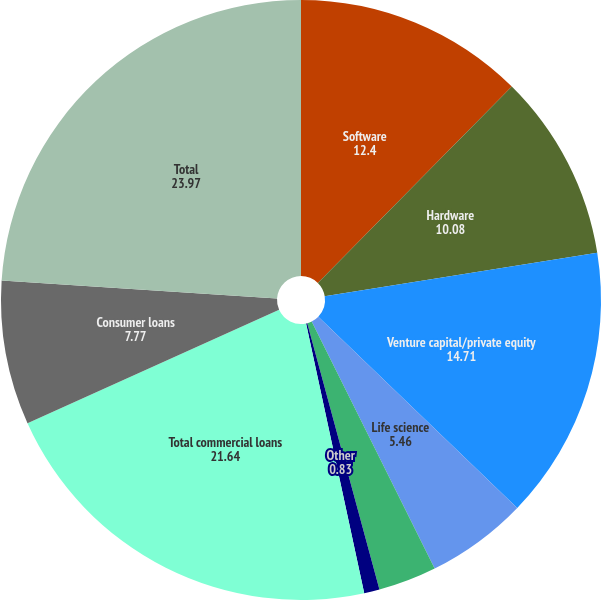<chart> <loc_0><loc_0><loc_500><loc_500><pie_chart><fcel>Software<fcel>Hardware<fcel>Venture capital/private equity<fcel>Life science<fcel>Premium wine<fcel>Other<fcel>Total commercial loans<fcel>Consumer loans<fcel>Total<nl><fcel>12.4%<fcel>10.08%<fcel>14.71%<fcel>5.46%<fcel>3.14%<fcel>0.83%<fcel>21.64%<fcel>7.77%<fcel>23.97%<nl></chart> 